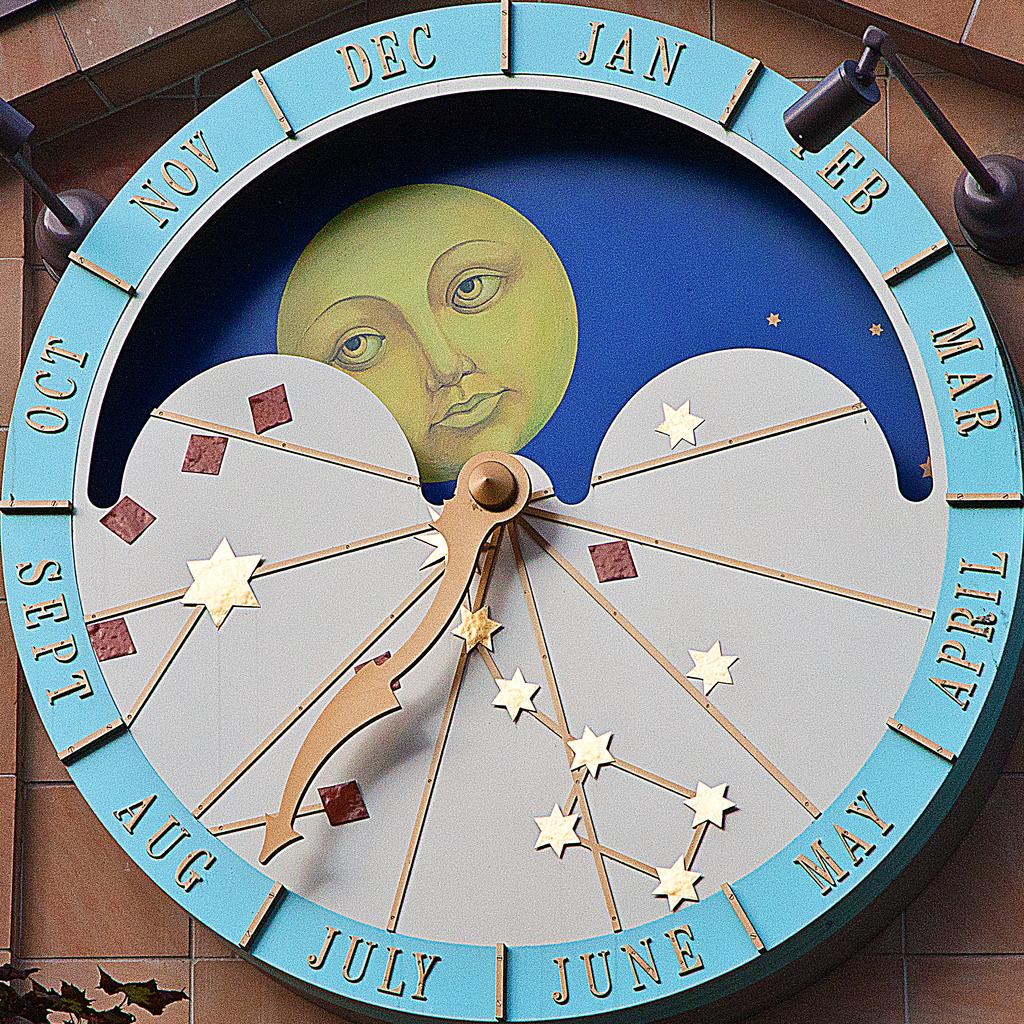<image>
Give a short and clear explanation of the subsequent image. A round dial has the months displayed, pointing to Aug. 